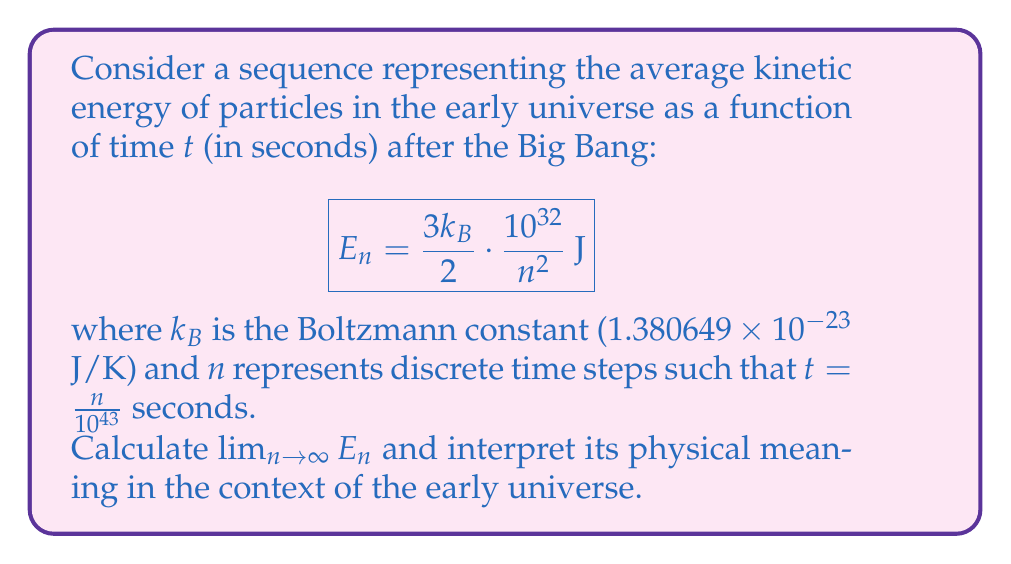Give your solution to this math problem. To solve this problem, we'll follow these steps:

1) First, let's examine the general form of the sequence:

   $$E_n = \frac{3k_B}{2} \cdot \frac{10^{32}}{n^2}$$

2) To find the limit as $n$ approaches infinity, we need to consider what happens to $\frac{1}{n^2}$ as $n$ gets very large:

   $$\lim_{n \to \infty} \frac{1}{n^2} = 0$$

3) Now, let's apply this to our full expression:

   $$\lim_{n \to \infty} E_n = \lim_{n \to \infty} \frac{3k_B}{2} \cdot \frac{10^{32}}{n^2}$$

   $$= \frac{3k_B}{2} \cdot 10^{32} \cdot \lim_{n \to \infty} \frac{1}{n^2}$$

   $$= \frac{3k_B}{2} \cdot 10^{32} \cdot 0 = 0$$

4) Let's calculate the exact value:

   $$\frac{3 \cdot (1.380649 \times 10^{-23})}{2} \cdot 10^{32} \cdot 0 = 0 \text{ J}$$

5) Physical interpretation:
   As $n$ approaches infinity, $t$ approaches infinity as well. This means that as time progresses long after the Big Bang, the average kinetic energy of particles approaches zero. This aligns with our understanding of the expanding and cooling universe. As the universe expands, particles spread out and interact less frequently, leading to a decrease in their average kinetic energy.
Answer: $\lim_{n \to \infty} E_n = 0 \text{ J}$

This result indicates that as time approaches infinity after the Big Bang, the average kinetic energy of particles in the universe approaches zero, consistent with the concept of an expanding and cooling universe. 